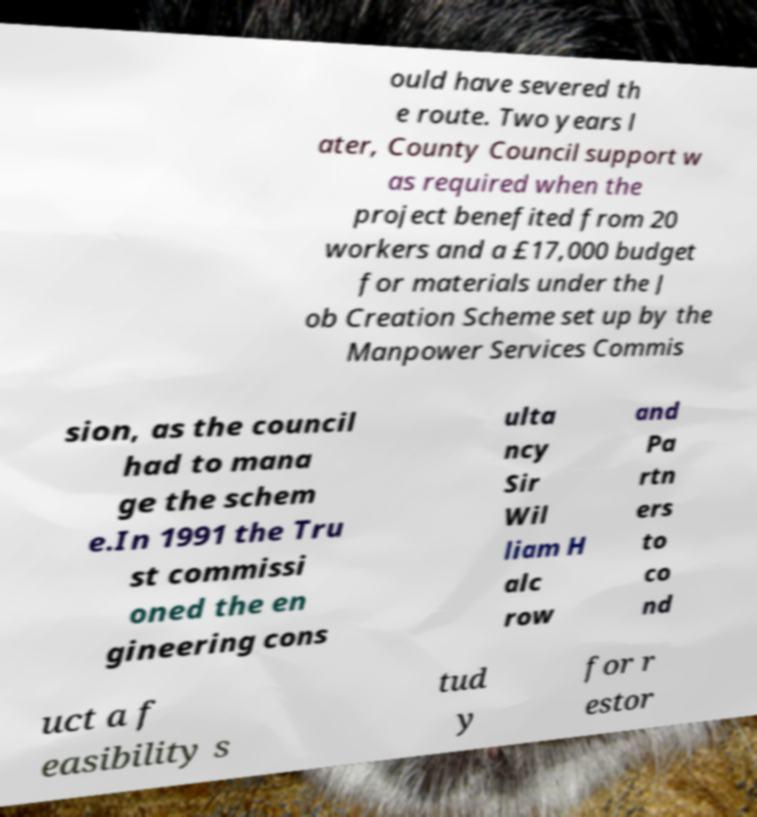I need the written content from this picture converted into text. Can you do that? ould have severed th e route. Two years l ater, County Council support w as required when the project benefited from 20 workers and a £17,000 budget for materials under the J ob Creation Scheme set up by the Manpower Services Commis sion, as the council had to mana ge the schem e.In 1991 the Tru st commissi oned the en gineering cons ulta ncy Sir Wil liam H alc row and Pa rtn ers to co nd uct a f easibility s tud y for r estor 